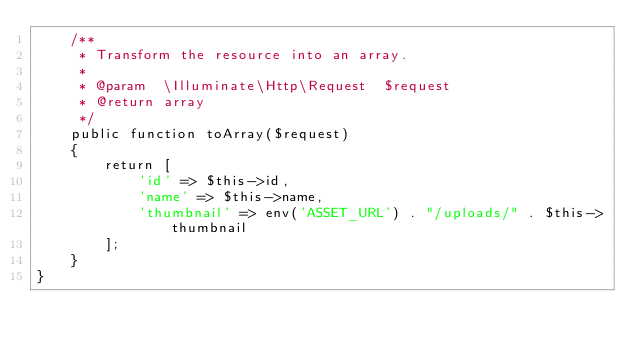Convert code to text. <code><loc_0><loc_0><loc_500><loc_500><_PHP_>    /**
     * Transform the resource into an array.
     *
     * @param  \Illuminate\Http\Request  $request
     * @return array
     */
    public function toArray($request)
    {
        return [
            'id' => $this->id,
            'name' => $this->name,
            'thumbnail' => env('ASSET_URL') . "/uploads/" . $this->thumbnail
        ];
    }
}
</code> 